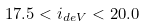Convert formula to latex. <formula><loc_0><loc_0><loc_500><loc_500>1 7 . 5 < i _ { d e V } < 2 0 . 0</formula> 